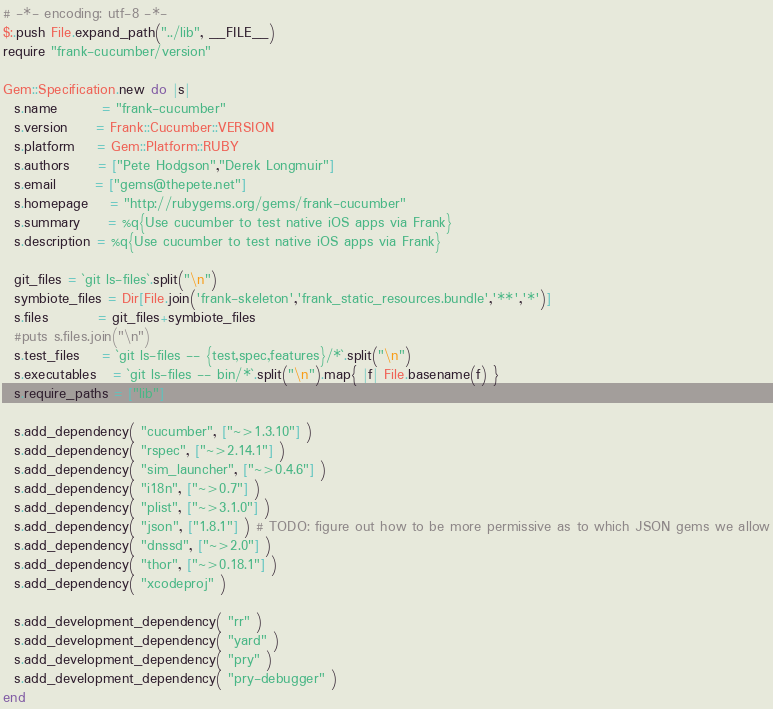<code> <loc_0><loc_0><loc_500><loc_500><_Ruby_># -*- encoding: utf-8 -*-
$:.push File.expand_path("../lib", __FILE__)
require "frank-cucumber/version"

Gem::Specification.new do |s|
  s.name        = "frank-cucumber"
  s.version     = Frank::Cucumber::VERSION
  s.platform    = Gem::Platform::RUBY
  s.authors     = ["Pete Hodgson","Derek Longmuir"]
  s.email       = ["gems@thepete.net"]
  s.homepage    = "http://rubygems.org/gems/frank-cucumber"
  s.summary     = %q{Use cucumber to test native iOS apps via Frank}
  s.description = %q{Use cucumber to test native iOS apps via Frank}

  git_files = `git ls-files`.split("\n")
  symbiote_files = Dir[File.join('frank-skeleton','frank_static_resources.bundle','**','*')]
  s.files         = git_files+symbiote_files
  #puts s.files.join("\n")
  s.test_files    = `git ls-files -- {test,spec,features}/*`.split("\n")
  s.executables   = `git ls-files -- bin/*`.split("\n").map{ |f| File.basename(f) }
  s.require_paths = ["lib"]

  s.add_dependency( "cucumber", ["~>1.3.10"] )
  s.add_dependency( "rspec", ["~>2.14.1"] )
  s.add_dependency( "sim_launcher", ["~>0.4.6"] )
  s.add_dependency( "i18n", ["~>0.7"] )
  s.add_dependency( "plist", ["~>3.1.0"] )
  s.add_dependency( "json", ["1.8.1"] ) # TODO: figure out how to be more permissive as to which JSON gems we allow
  s.add_dependency( "dnssd", ["~>2.0"] )
  s.add_dependency( "thor", ["~>0.18.1"] )
  s.add_dependency( "xcodeproj" )

  s.add_development_dependency( "rr" )
  s.add_development_dependency( "yard" )
  s.add_development_dependency( "pry" )
  s.add_development_dependency( "pry-debugger" )
end
</code> 